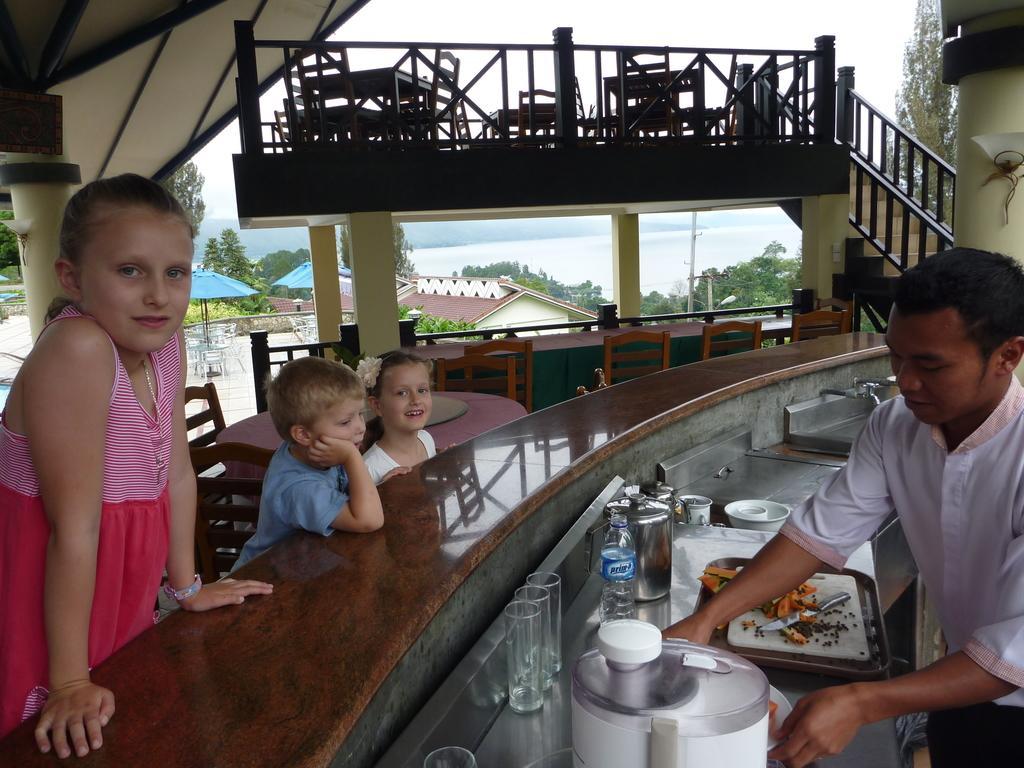Could you give a brief overview of what you see in this image? On the right there is a man who is wearing white shirt and trouser. He is standing near to the table. On the table we can see the tray, plates, knife, carrot, water bottles, glass, rice cooker, washbasin, cup, saucer and other objects. Beside the table there are three children's was standing near to the chairs. At the top we can see tables and chairs near to the wooden stairs. In the background we can see umbrella, building, shed, trees, plants, river and mountain. Here it's a sky. 